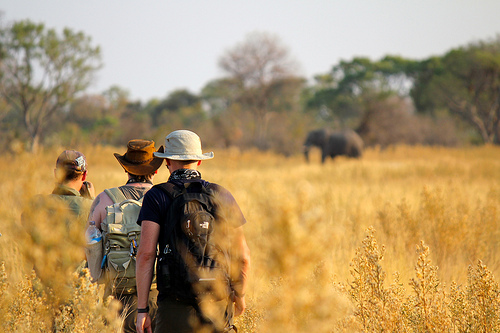What are the men in the grass doing? The men in the grass are standing. 